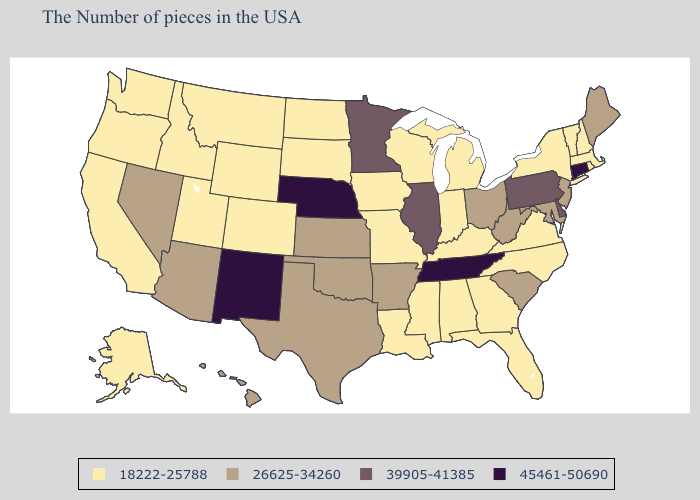Name the states that have a value in the range 18222-25788?
Answer briefly. Massachusetts, Rhode Island, New Hampshire, Vermont, New York, Virginia, North Carolina, Florida, Georgia, Michigan, Kentucky, Indiana, Alabama, Wisconsin, Mississippi, Louisiana, Missouri, Iowa, South Dakota, North Dakota, Wyoming, Colorado, Utah, Montana, Idaho, California, Washington, Oregon, Alaska. What is the lowest value in the Northeast?
Keep it brief. 18222-25788. What is the highest value in states that border Arizona?
Write a very short answer. 45461-50690. What is the value of Georgia?
Give a very brief answer. 18222-25788. Name the states that have a value in the range 39905-41385?
Give a very brief answer. Delaware, Pennsylvania, Illinois, Minnesota. Does the map have missing data?
Be succinct. No. Which states have the lowest value in the South?
Give a very brief answer. Virginia, North Carolina, Florida, Georgia, Kentucky, Alabama, Mississippi, Louisiana. Does Idaho have a lower value than Alaska?
Be succinct. No. Which states hav the highest value in the MidWest?
Write a very short answer. Nebraska. Does Illinois have the lowest value in the MidWest?
Short answer required. No. Name the states that have a value in the range 18222-25788?
Concise answer only. Massachusetts, Rhode Island, New Hampshire, Vermont, New York, Virginia, North Carolina, Florida, Georgia, Michigan, Kentucky, Indiana, Alabama, Wisconsin, Mississippi, Louisiana, Missouri, Iowa, South Dakota, North Dakota, Wyoming, Colorado, Utah, Montana, Idaho, California, Washington, Oregon, Alaska. Name the states that have a value in the range 18222-25788?
Concise answer only. Massachusetts, Rhode Island, New Hampshire, Vermont, New York, Virginia, North Carolina, Florida, Georgia, Michigan, Kentucky, Indiana, Alabama, Wisconsin, Mississippi, Louisiana, Missouri, Iowa, South Dakota, North Dakota, Wyoming, Colorado, Utah, Montana, Idaho, California, Washington, Oregon, Alaska. What is the value of Connecticut?
Concise answer only. 45461-50690. What is the lowest value in the USA?
Keep it brief. 18222-25788. 